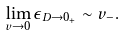<formula> <loc_0><loc_0><loc_500><loc_500>\lim _ { v \rightarrow 0 } \epsilon _ { D \rightarrow 0 _ { + } } \sim v _ { - } .</formula> 